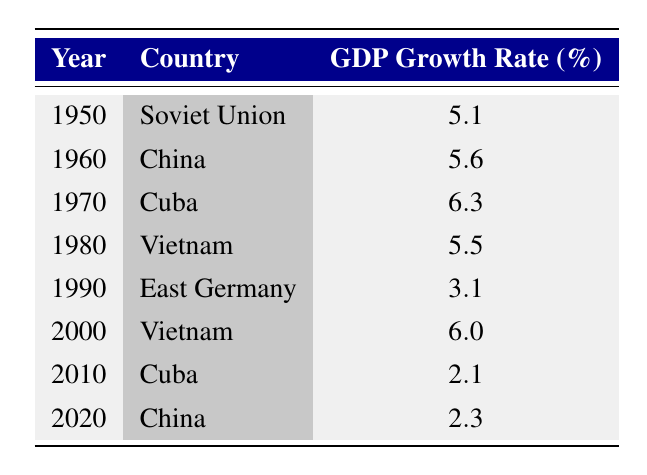What was the GDP growth rate of Cuba in 1970? The table indicates that in 1970, Cuba had a GDP growth rate of 6.3%, which is stated directly under the corresponding year and country.
Answer: 6.3% Which country had the highest GDP growth rate recorded in the table? Looking at the GDP growth rates listed, 6.3% for Cuba in 1970 is the highest figure present in the table.
Answer: Cuba What is the average GDP growth rate from 1950 to 2020? To calculate the average, sum all the GDP growth rates: (5.1 + 5.6 + 6.3 + 5.5 + 3.1 + 6.0 + 2.1 + 2.3) = 35.0. There are 8 data points, so the average is 35.0 / 8 = 4.375.
Answer: 4.375 Did East Germany have a higher GDP growth rate than Vietnam in 1980? In 1980, Vietnam had a GDP growth rate of 5.5%, whereas East Germany's GDP growth rate in 1990 was 3.1%. Since these years are different, we can't directly compare their values from the table. Thus, the answer is no.
Answer: No What is the difference in GDP growth rates between Cuba in 1970 and Cuba in 2010? The GDP growth rate for Cuba in 1970 was 6.3% and in 2010 it was 2.1%. The difference is calculated as 6.3 - 2.1 = 4.2%.
Answer: 4.2% Which countries had a GDP growth rate above 5% during this period? From the table, the countries with GDP growth rates above 5% are Soviet Union (5.1%), China (5.6%), Cuba (6.3%), and Vietnam (5.5% and 6.0%).
Answer: Soviet Union, China, Cuba, Vietnam Was the GDP growth rate in Vietnam in 2000 higher than the rate in China in 2020? The GDP growth rate for Vietnam in 2000 was 6.0% and for China in 2020 was 2.3%. Since 6.0% > 2.3%, this statement is true.
Answer: Yes Identify the years in which China had a GDP growth rate recorded. The table shows that China had GDP growth rates in 1960 (5.6%) and in 2020 (2.3%). These two entries represent the years China is recorded in the table.
Answer: 1960, 2020 